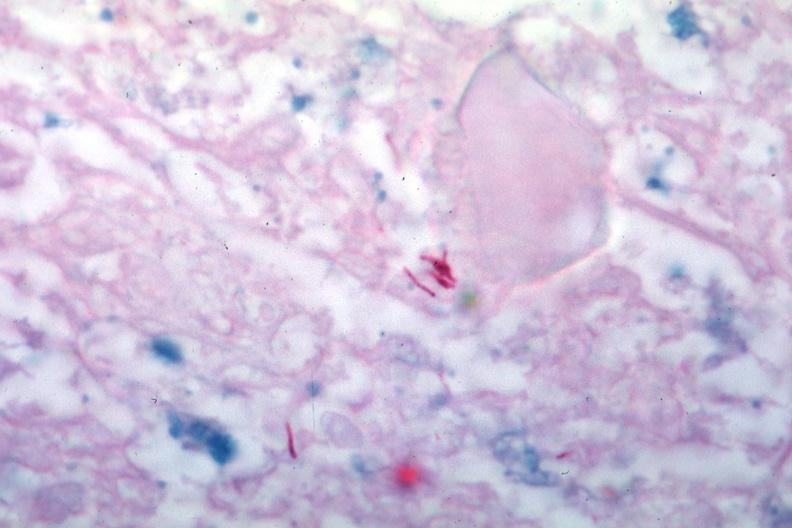what does this image show?
Answer the question using a single word or phrase. Acid fast stain several typical mycobacteria 